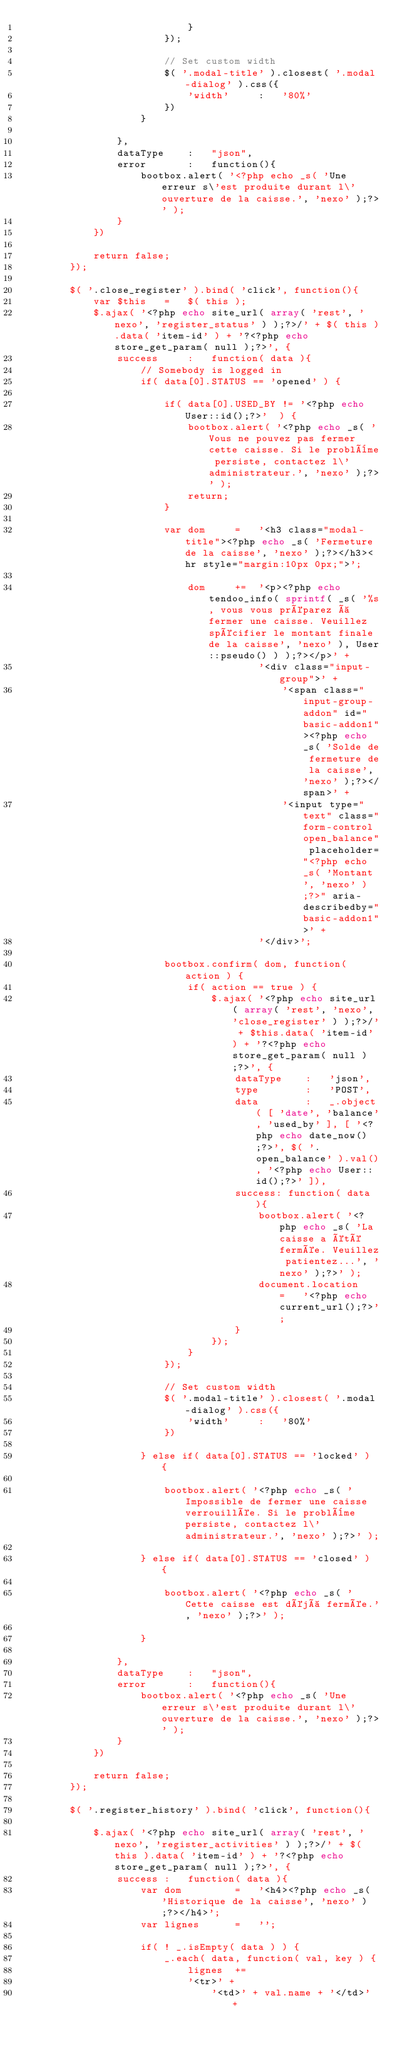<code> <loc_0><loc_0><loc_500><loc_500><_PHP_>                            }
                        });

                        // Set custom width
                        $( '.modal-title' ).closest( '.modal-dialog' ).css({
                            'width'		:	'80%'
                        })
                    }

                },
                dataType	:	"json",
                error		:	function(){
                    bootbox.alert( '<?php echo _s( 'Une erreur s\'est produite durant l\'ouverture de la caisse.', 'nexo' );?>' );
                }
            })

            return false;
        });

        $( '.close_register' ).bind( 'click', function(){
            var $this	=	$( this );
            $.ajax( '<?php echo site_url( array( 'rest', 'nexo', 'register_status' ) );?>/' + $( this ).data( 'item-id' ) + '?<?php echo store_get_param( null );?>', {
                success		:	function( data ){
                    // Somebody is logged in
                    if( data[0].STATUS == 'opened' ) {

                        if( data[0].USED_BY != '<?php echo User::id();?>'  ) {
                            bootbox.alert( '<?php echo _s( 'Vous ne pouvez pas fermer cette caisse. Si le problème persiste, contactez l\'administrateur.', 'nexo' );?>' );
                            return;
                        }

                        var dom		=	'<h3 class="modal-title"><?php echo _s( 'Fermeture de la caisse', 'nexo' );?></h3><hr style="margin:10px 0px;">';

                            dom		+=	'<p><?php echo tendoo_info( sprintf( _s( '%s, vous vous préparez à fermer une caisse. Veuillez spécifier le montant finale de la caisse', 'nexo' ), User::pseudo() ) );?></p>' +
                                        '<div class="input-group">' +
                                            '<span class="input-group-addon" id="basic-addon1"><?php echo _s( 'Solde de fermeture de la caisse', 'nexo' );?></span>' +
                                            '<input type="text" class="form-control open_balance" placeholder="<?php echo _s( 'Montant', 'nexo' );?>" aria-describedby="basic-addon1">' +
                                        '</div>';

                        bootbox.confirm( dom, function( action ) {
                            if( action == true ) {
                                $.ajax( '<?php echo site_url( array( 'rest', 'nexo', 'close_register' ) );?>/' + $this.data( 'item-id' ) + '?<?php echo store_get_param( null );?>', {
                                    dataType	:	'json',
                                    type		:	'POST',
                                    data		:	_.object( [ 'date', 'balance', 'used_by' ], [ '<?php echo date_now();?>', $( '.open_balance' ).val(), '<?php echo User::id();?>' ]),
                                    success: function( data ){
                                        bootbox.alert( '<?php echo _s( 'La caisse a été fermée. Veuillez patientez...', 'nexo' );?>' );
                                        document.location	=	'<?php echo current_url();?>';
                                    }
                                });
                            }
                        });

                        // Set custom width
                        $( '.modal-title' ).closest( '.modal-dialog' ).css({
                            'width'		:	'80%'
                        })

                    } else if( data[0].STATUS == 'locked' ) {

                        bootbox.alert( '<?php echo _s( 'Impossible de fermer une caisse verrouillée. Si le problème persiste, contactez l\'administrateur.', 'nexo' );?>' );

                    } else if( data[0].STATUS == 'closed' ) {

                        bootbox.alert( '<?php echo _s( 'Cette caisse est déjà fermée.', 'nexo' );?>' );

                    }

                },
                dataType	:	"json",
                error		:	function(){
                    bootbox.alert( '<?php echo _s( 'Une erreur s\'est produite durant l\'ouverture de la caisse.', 'nexo' );?>' );
                }
            })

            return false;
        });

        $( '.register_history' ).bind( 'click', function(){

            $.ajax( '<?php echo site_url( array( 'rest', 'nexo', 'register_activities' ) );?>/' + $( this ).data( 'item-id' ) + '?<?php echo store_get_param( null );?>', {
                success	:	function( data ){
                    var dom			=	'<h4><?php echo _s( 'Historique de la caisse', 'nexo' );?></h4>';
                    var lignes		=	'';

                    if( ! _.isEmpty( data ) ) {
                        _.each( data, function( val, key ) {
                            lignes 	+=
                            '<tr>' +
                                '<td>' + val.name + '</td>' +</code> 